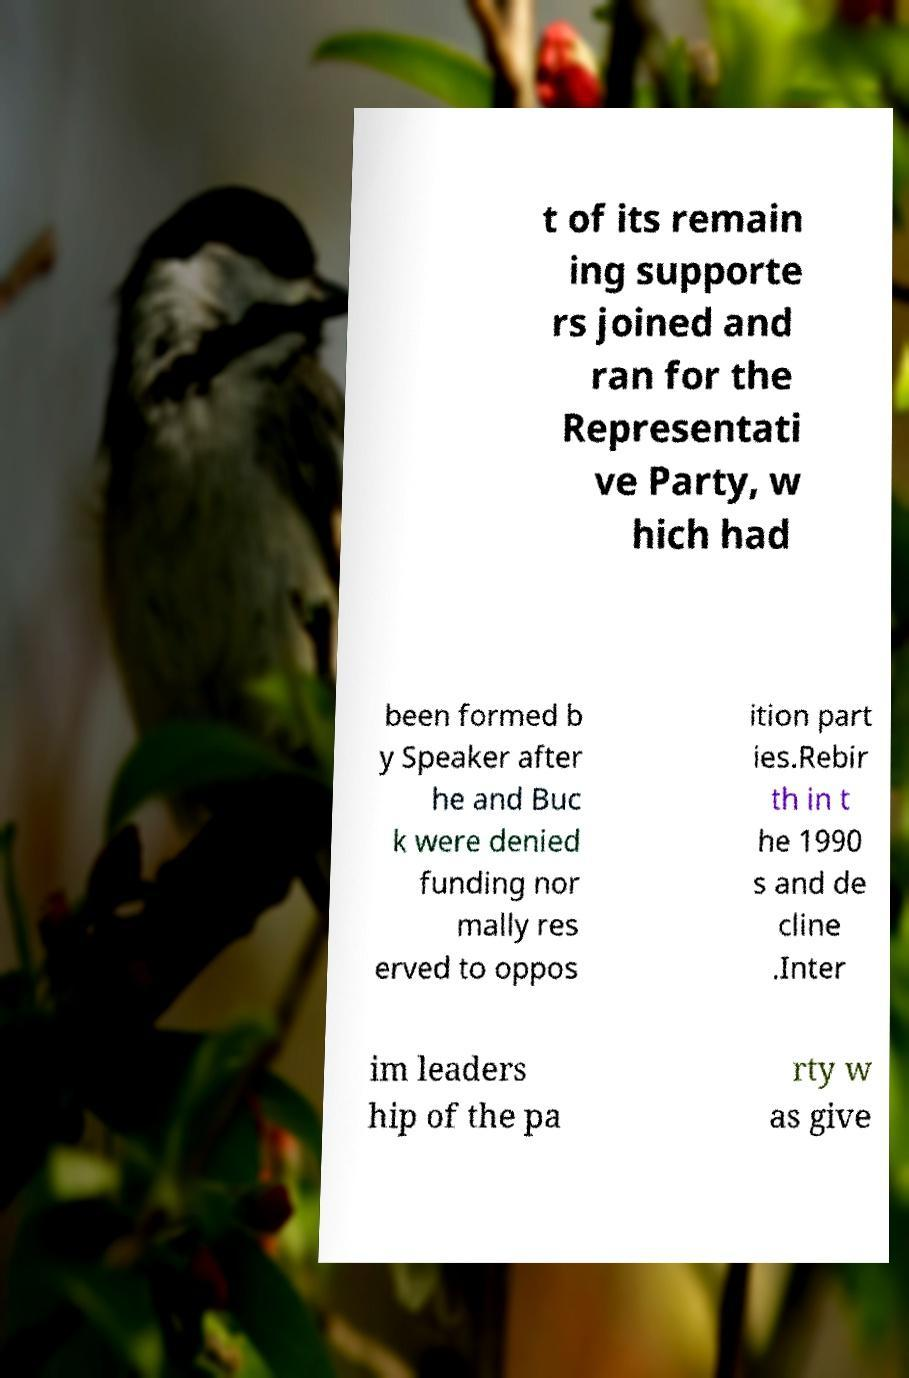For documentation purposes, I need the text within this image transcribed. Could you provide that? t of its remain ing supporte rs joined and ran for the Representati ve Party, w hich had been formed b y Speaker after he and Buc k were denied funding nor mally res erved to oppos ition part ies.Rebir th in t he 1990 s and de cline .Inter im leaders hip of the pa rty w as give 